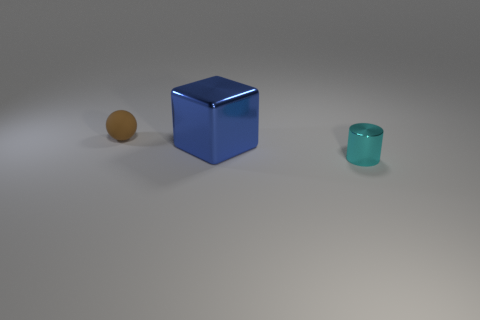How many other things are the same shape as the large metallic thing?
Provide a short and direct response. 0. There is a metallic object that is behind the tiny object in front of the small object that is behind the big cube; what is its size?
Offer a very short reply. Large. How many blue objects are matte objects or metal cubes?
Give a very brief answer. 1. What shape is the tiny object behind the small object that is on the right side of the blue block?
Provide a short and direct response. Sphere. There is a metallic thing to the right of the big blue thing; is its size the same as the metal object to the left of the cyan cylinder?
Your response must be concise. No. Are there any tiny brown balls that have the same material as the small cyan object?
Keep it short and to the point. No. Is there a thing in front of the tiny object that is behind the small thing on the right side of the rubber thing?
Your answer should be compact. Yes. There is a large shiny block; are there any brown objects on the left side of it?
Provide a succinct answer. Yes. There is a thing that is to the left of the big blue metal block; what number of things are to the right of it?
Your answer should be compact. 2. Do the brown thing and the metallic object in front of the big blue object have the same size?
Provide a short and direct response. Yes. 